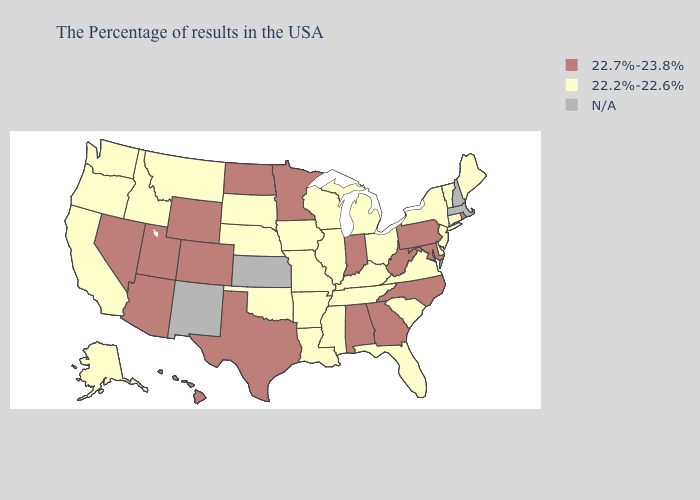What is the value of Idaho?
Quick response, please. 22.2%-22.6%. What is the highest value in the USA?
Answer briefly. 22.7%-23.8%. What is the lowest value in the USA?
Quick response, please. 22.2%-22.6%. What is the value of Illinois?
Keep it brief. 22.2%-22.6%. Does Georgia have the highest value in the USA?
Short answer required. Yes. What is the value of Massachusetts?
Write a very short answer. N/A. Which states have the lowest value in the MidWest?
Answer briefly. Ohio, Michigan, Wisconsin, Illinois, Missouri, Iowa, Nebraska, South Dakota. What is the value of Rhode Island?
Short answer required. 22.7%-23.8%. What is the highest value in the USA?
Concise answer only. 22.7%-23.8%. What is the lowest value in the MidWest?
Quick response, please. 22.2%-22.6%. What is the value of New Hampshire?
Answer briefly. N/A. What is the value of New Jersey?
Keep it brief. 22.2%-22.6%. 